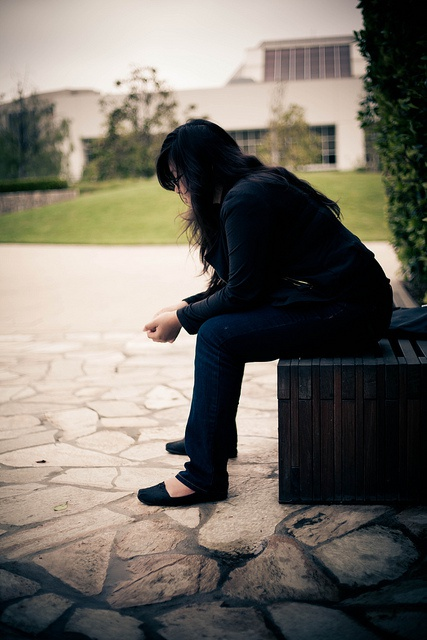Describe the objects in this image and their specific colors. I can see people in gray, black, navy, and lightgray tones and bench in gray, black, and darkblue tones in this image. 